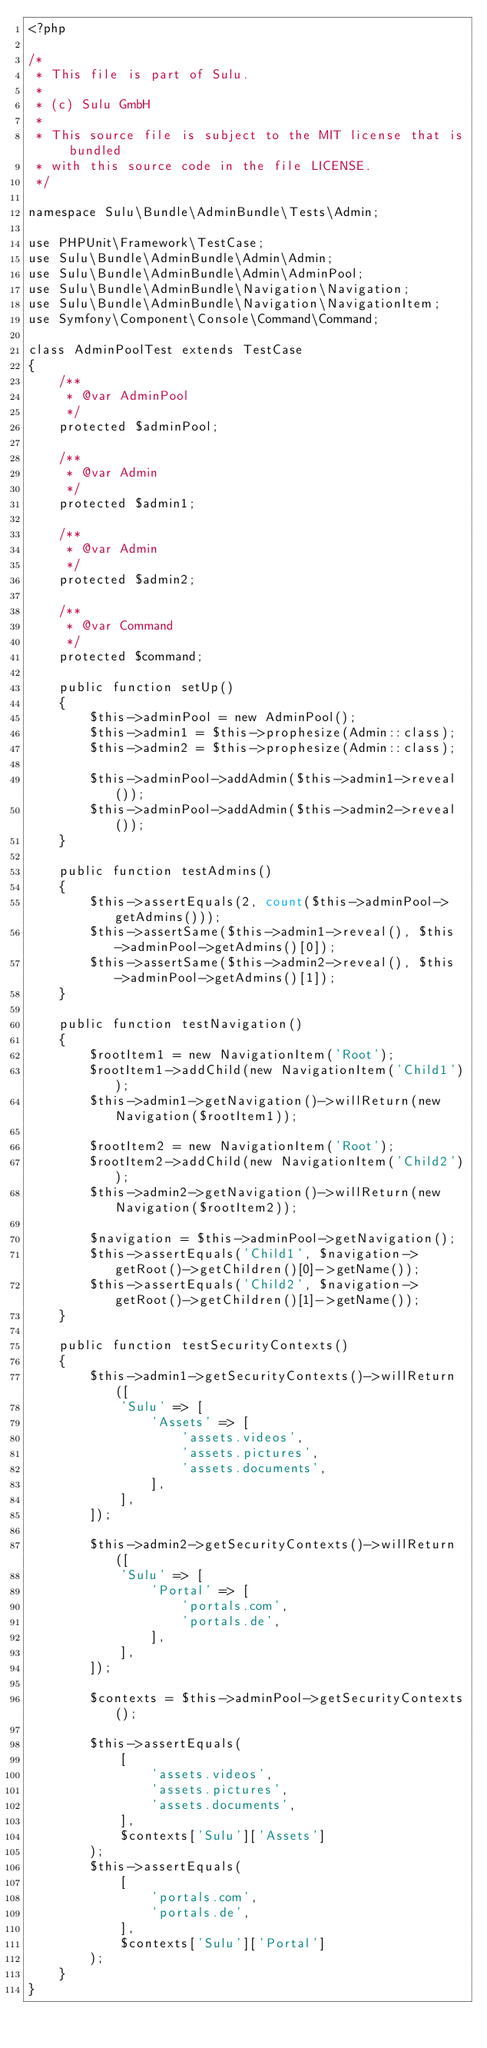<code> <loc_0><loc_0><loc_500><loc_500><_PHP_><?php

/*
 * This file is part of Sulu.
 *
 * (c) Sulu GmbH
 *
 * This source file is subject to the MIT license that is bundled
 * with this source code in the file LICENSE.
 */

namespace Sulu\Bundle\AdminBundle\Tests\Admin;

use PHPUnit\Framework\TestCase;
use Sulu\Bundle\AdminBundle\Admin\Admin;
use Sulu\Bundle\AdminBundle\Admin\AdminPool;
use Sulu\Bundle\AdminBundle\Navigation\Navigation;
use Sulu\Bundle\AdminBundle\Navigation\NavigationItem;
use Symfony\Component\Console\Command\Command;

class AdminPoolTest extends TestCase
{
    /**
     * @var AdminPool
     */
    protected $adminPool;

    /**
     * @var Admin
     */
    protected $admin1;

    /**
     * @var Admin
     */
    protected $admin2;

    /**
     * @var Command
     */
    protected $command;

    public function setUp()
    {
        $this->adminPool = new AdminPool();
        $this->admin1 = $this->prophesize(Admin::class);
        $this->admin2 = $this->prophesize(Admin::class);

        $this->adminPool->addAdmin($this->admin1->reveal());
        $this->adminPool->addAdmin($this->admin2->reveal());
    }

    public function testAdmins()
    {
        $this->assertEquals(2, count($this->adminPool->getAdmins()));
        $this->assertSame($this->admin1->reveal(), $this->adminPool->getAdmins()[0]);
        $this->assertSame($this->admin2->reveal(), $this->adminPool->getAdmins()[1]);
    }

    public function testNavigation()
    {
        $rootItem1 = new NavigationItem('Root');
        $rootItem1->addChild(new NavigationItem('Child1'));
        $this->admin1->getNavigation()->willReturn(new Navigation($rootItem1));

        $rootItem2 = new NavigationItem('Root');
        $rootItem2->addChild(new NavigationItem('Child2'));
        $this->admin2->getNavigation()->willReturn(new Navigation($rootItem2));

        $navigation = $this->adminPool->getNavigation();
        $this->assertEquals('Child1', $navigation->getRoot()->getChildren()[0]->getName());
        $this->assertEquals('Child2', $navigation->getRoot()->getChildren()[1]->getName());
    }

    public function testSecurityContexts()
    {
        $this->admin1->getSecurityContexts()->willReturn([
            'Sulu' => [
                'Assets' => [
                    'assets.videos',
                    'assets.pictures',
                    'assets.documents',
                ],
            ],
        ]);

        $this->admin2->getSecurityContexts()->willReturn([
            'Sulu' => [
                'Portal' => [
                    'portals.com',
                    'portals.de',
                ],
            ],
        ]);

        $contexts = $this->adminPool->getSecurityContexts();

        $this->assertEquals(
            [
                'assets.videos',
                'assets.pictures',
                'assets.documents',
            ],
            $contexts['Sulu']['Assets']
        );
        $this->assertEquals(
            [
                'portals.com',
                'portals.de',
            ],
            $contexts['Sulu']['Portal']
        );
    }
}
</code> 